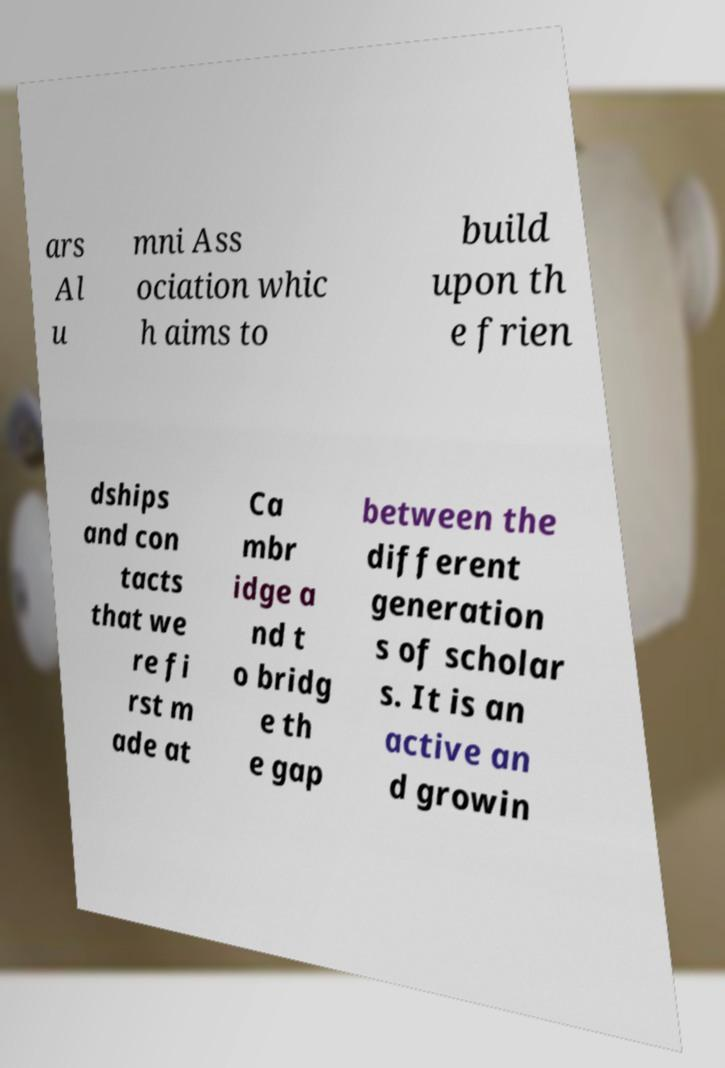For documentation purposes, I need the text within this image transcribed. Could you provide that? ars Al u mni Ass ociation whic h aims to build upon th e frien dships and con tacts that we re fi rst m ade at Ca mbr idge a nd t o bridg e th e gap between the different generation s of scholar s. It is an active an d growin 